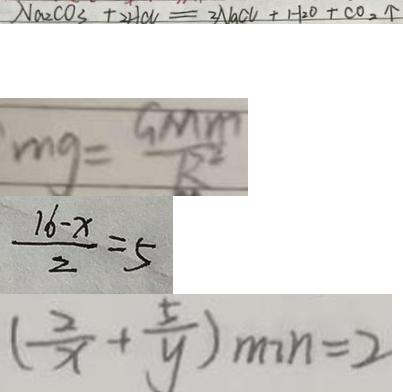<formula> <loc_0><loc_0><loc_500><loc_500>N a _ { 2 } C O _ { 3 } + 2 H C N = 2 N a C U + H _ { 2 } O + C O _ { 2 } \uparrow 
 m g = \frac { G M m } { R ^ { 2 } } 
 \frac { 1 6 - x } { 2 } = 5 
 ( \frac { 2 } { x } + \frac { 5 } { y } ) _ { \min } = 2</formula> 